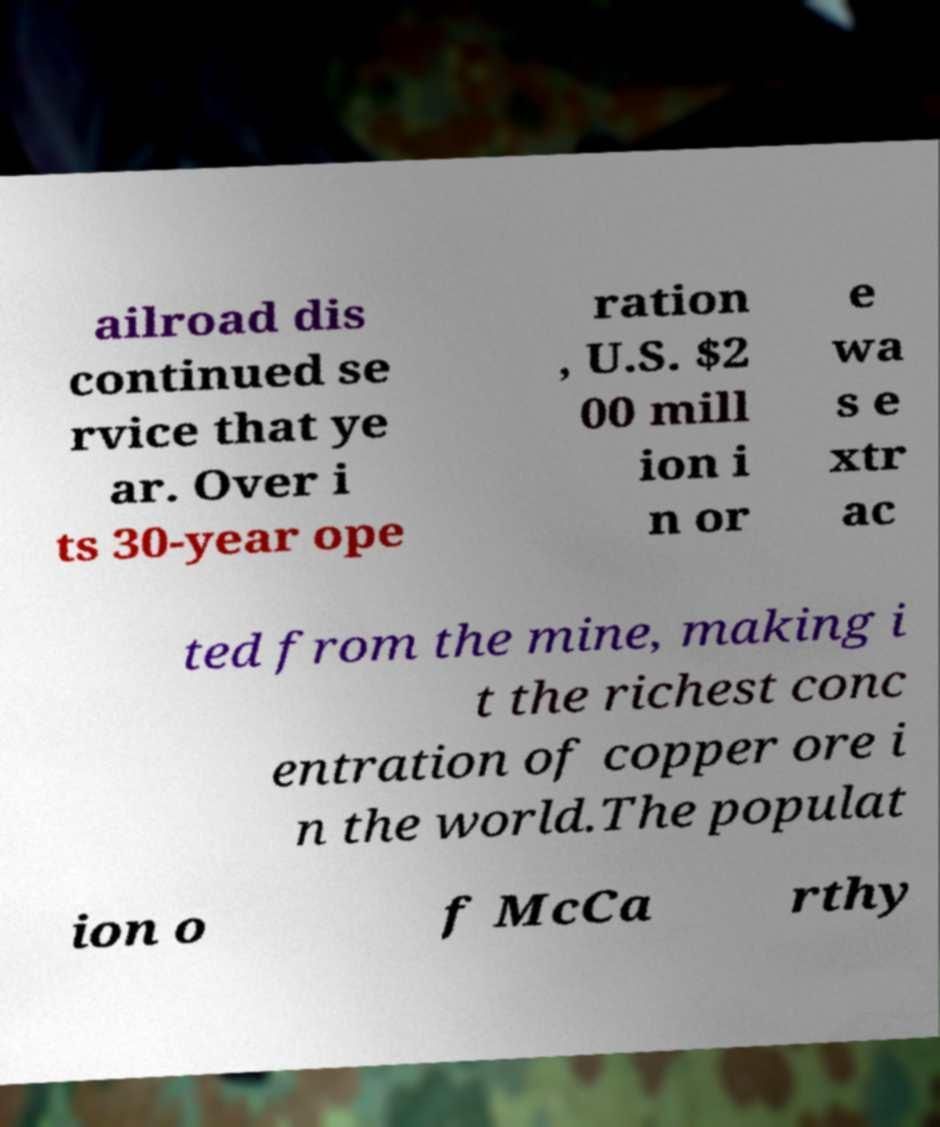Can you accurately transcribe the text from the provided image for me? ailroad dis continued se rvice that ye ar. Over i ts 30-year ope ration , U.S. $2 00 mill ion i n or e wa s e xtr ac ted from the mine, making i t the richest conc entration of copper ore i n the world.The populat ion o f McCa rthy 